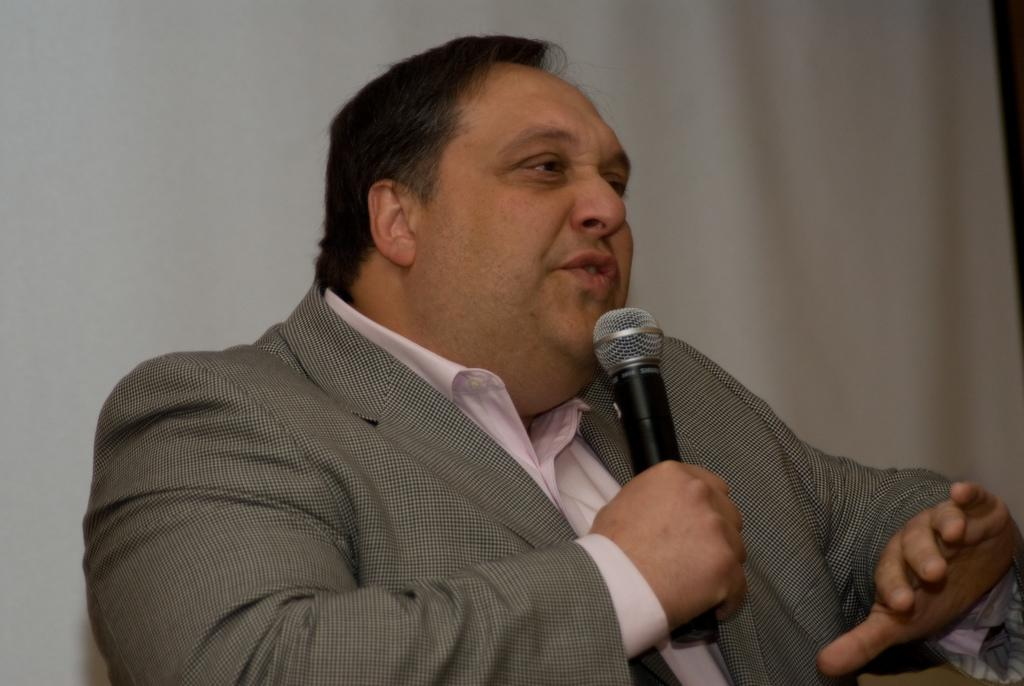Who is present in the image? There is a man in the image. What is the man wearing? The man is wearing a suit. What is the man doing in the image? The man is talking and holding a microphone. What can be seen in the background of the image? There is a curtain in the background of the image. What type of church is visible in the background of the image? There is no church visible in the background of the image; it features a curtain instead. 